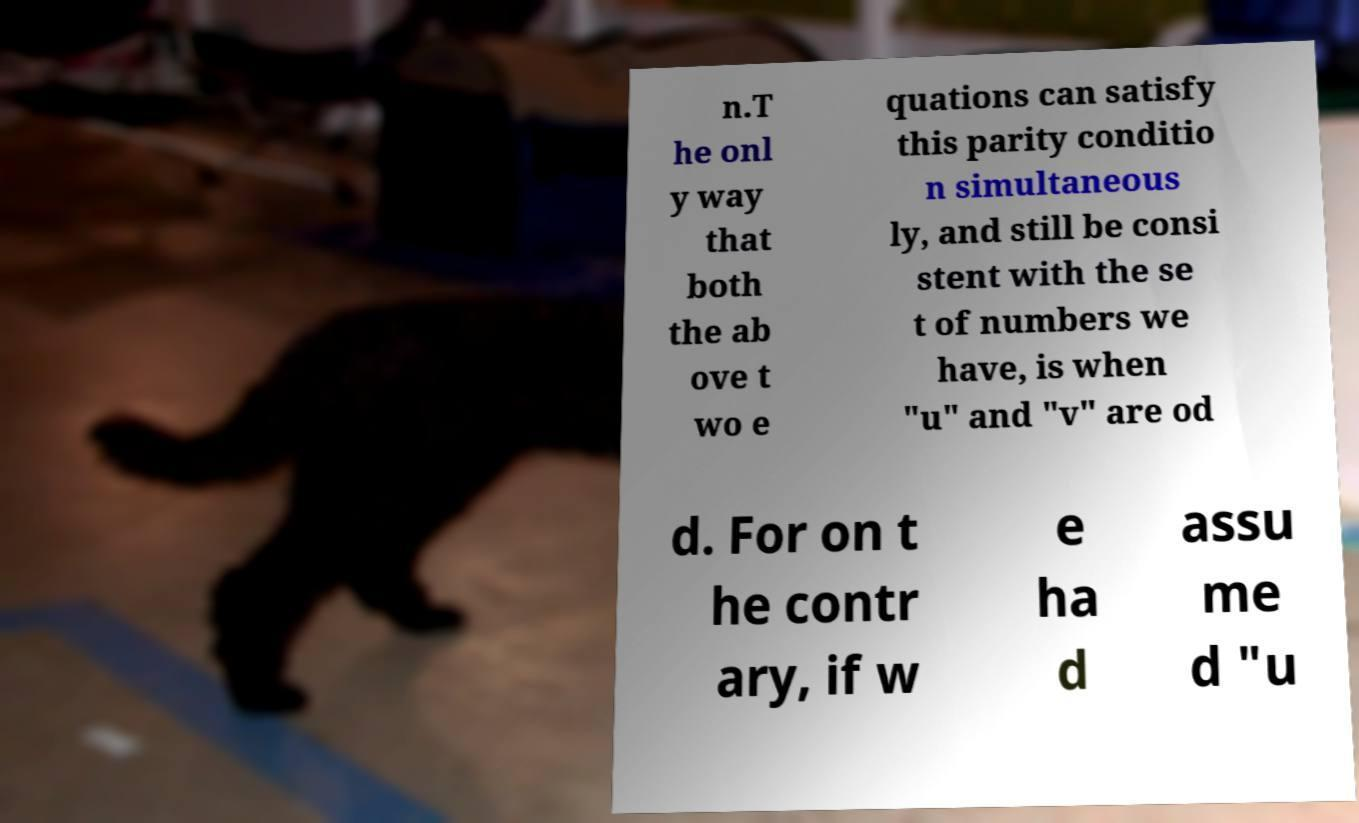Please read and relay the text visible in this image. What does it say? n.T he onl y way that both the ab ove t wo e quations can satisfy this parity conditio n simultaneous ly, and still be consi stent with the se t of numbers we have, is when "u" and "v" are od d. For on t he contr ary, if w e ha d assu me d "u 